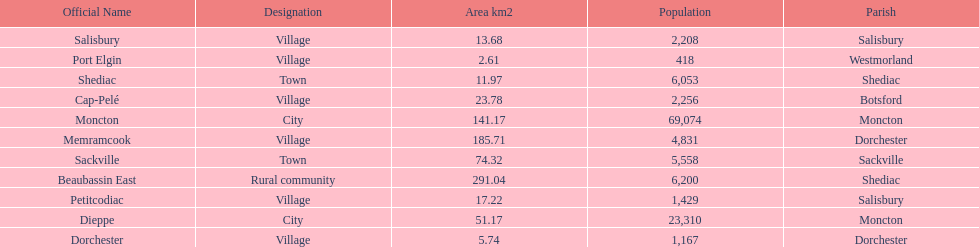How many municipalities have areas that are below 50 square kilometers? 6. Give me the full table as a dictionary. {'header': ['Official Name', 'Designation', 'Area km2', 'Population', 'Parish'], 'rows': [['Salisbury', 'Village', '13.68', '2,208', 'Salisbury'], ['Port Elgin', 'Village', '2.61', '418', 'Westmorland'], ['Shediac', 'Town', '11.97', '6,053', 'Shediac'], ['Cap-Pelé', 'Village', '23.78', '2,256', 'Botsford'], ['Moncton', 'City', '141.17', '69,074', 'Moncton'], ['Memramcook', 'Village', '185.71', '4,831', 'Dorchester'], ['Sackville', 'Town', '74.32', '5,558', 'Sackville'], ['Beaubassin East', 'Rural community', '291.04', '6,200', 'Shediac'], ['Petitcodiac', 'Village', '17.22', '1,429', 'Salisbury'], ['Dieppe', 'City', '51.17', '23,310', 'Moncton'], ['Dorchester', 'Village', '5.74', '1,167', 'Dorchester']]} 